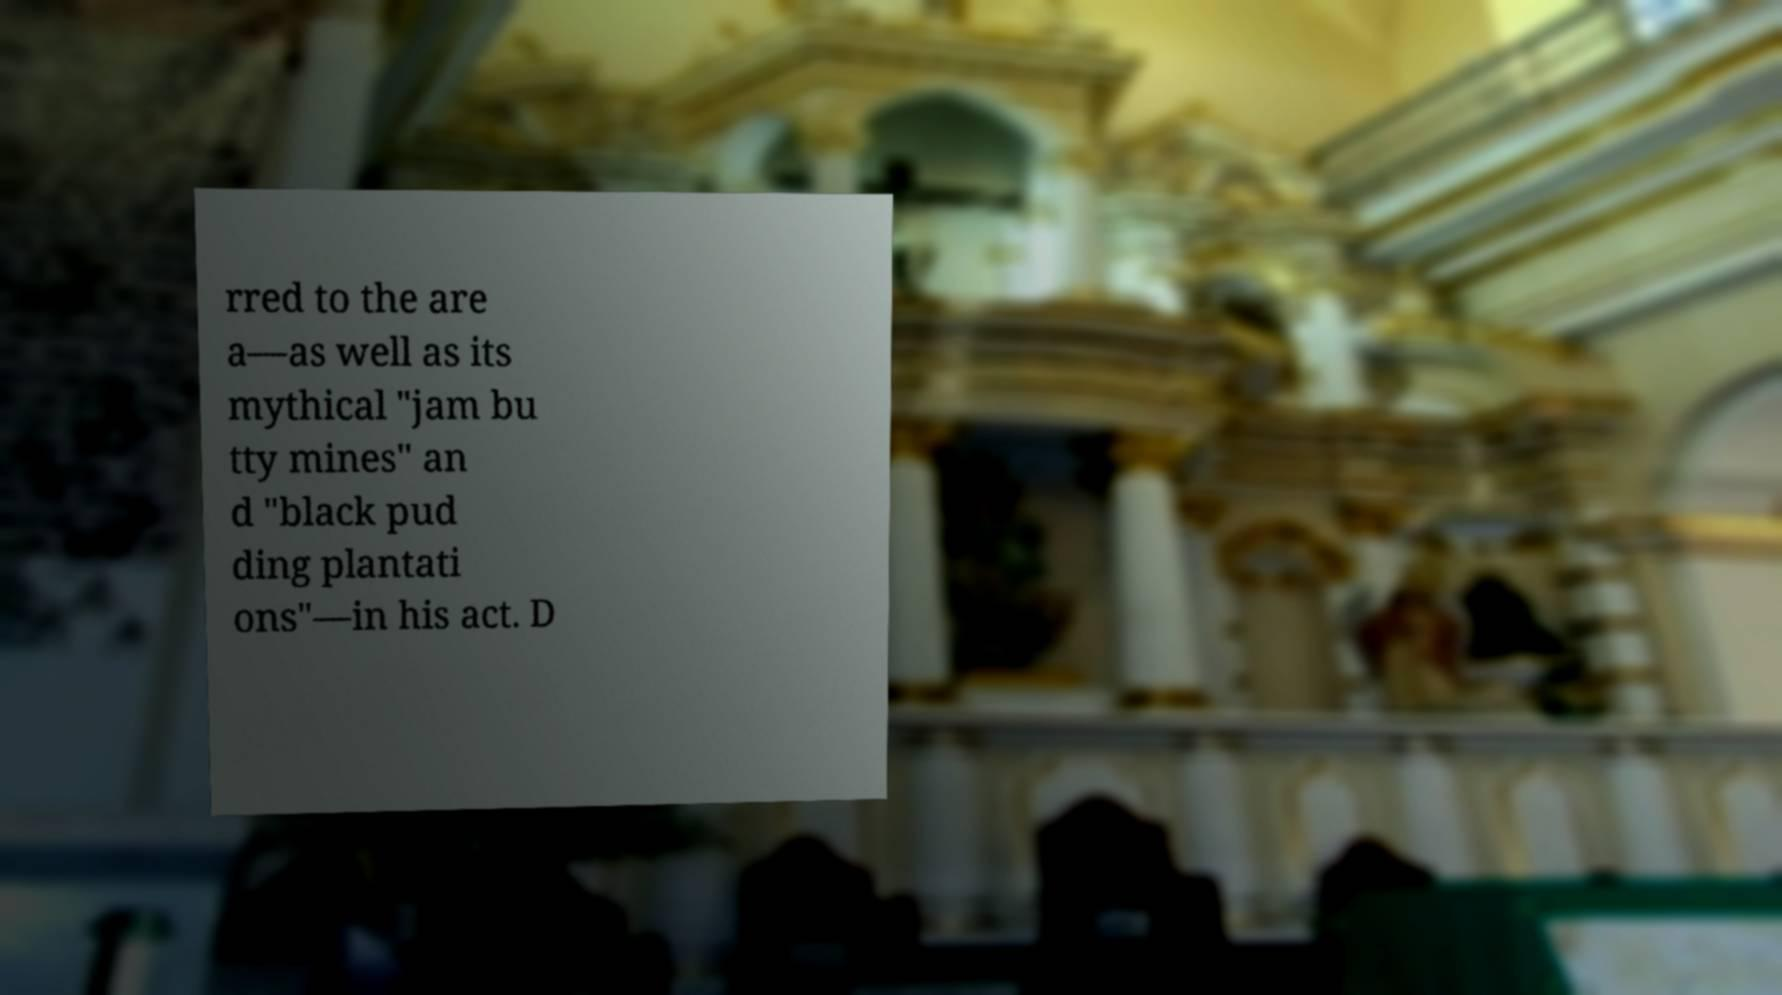Please identify and transcribe the text found in this image. rred to the are a—as well as its mythical "jam bu tty mines" an d "black pud ding plantati ons"—in his act. D 